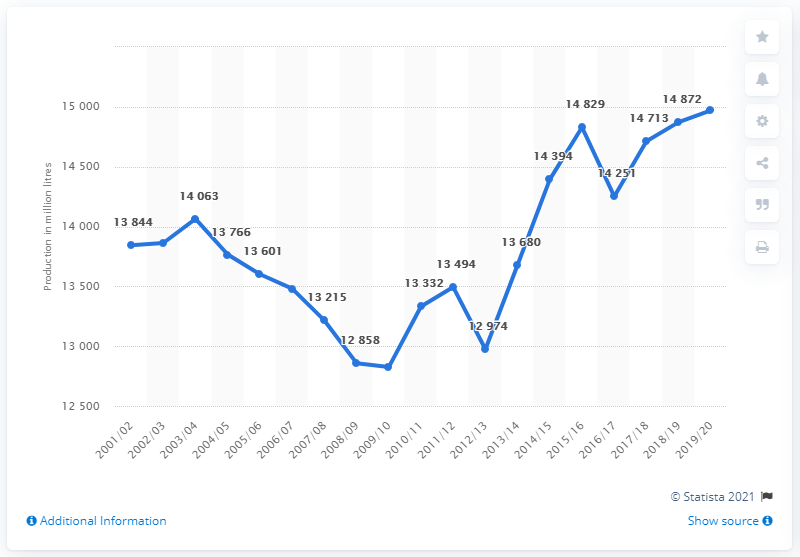Draw attention to some important aspects in this diagram. According to the latest data from 2019/20, the amount of milk produced in the UK was 14,970 metric tons. 